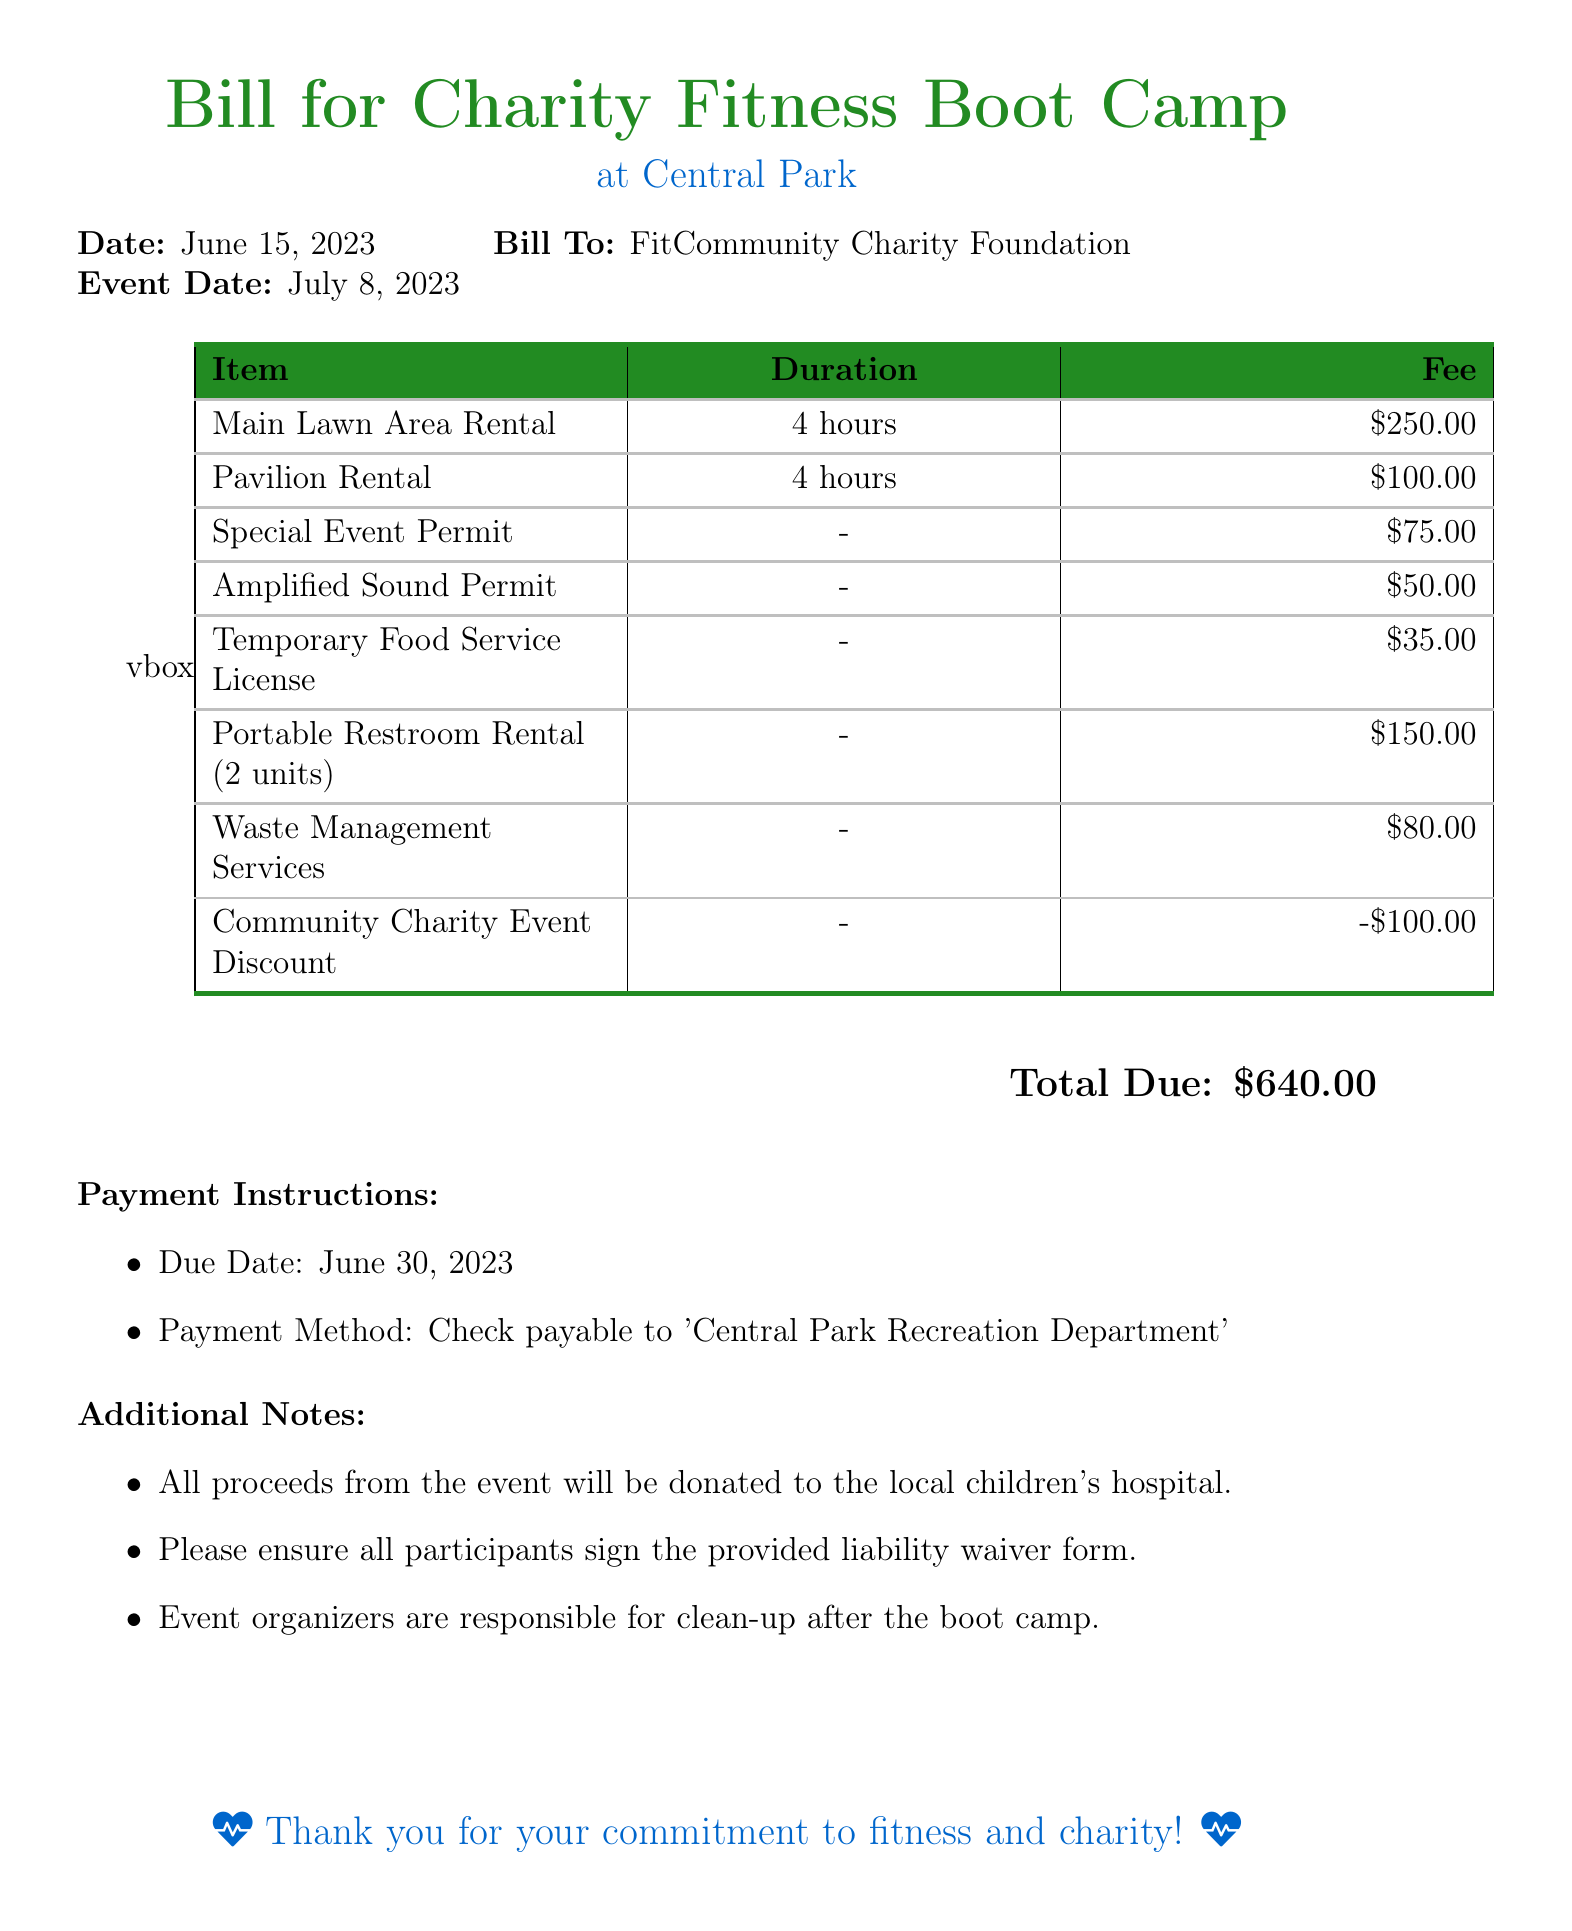What is the event date? The event date is specified in the document as July 8, 2023.
Answer: July 8, 2023 Who is the bill addressed to? The bill is addressed to the FitCommunity Charity Foundation.
Answer: FitCommunity Charity Foundation What is the fee for the Main Lawn Area Rental? The fee for the Main Lawn Area Rental is listed in the table as $250.00.
Answer: $250.00 What is the total due amount? The total due amount is calculated from the itemized fees, which is $640.00.
Answer: $640.00 What is the due date for payment? The due date for payment is June 30, 2023, as stated in the payment instructions.
Answer: June 30, 2023 Is there a discount applied? The document mentions a Community Charity Event Discount of $100.00.
Answer: $100.00 What services are included under Waste Management Services? The document indicates that Waste Management Services costs $80.00, but does not list specific services provided.
Answer: $80.00 What should participants sign? The document notes that all participants must sign a provided liability waiver form.
Answer: liability waiver form What will the proceeds from the event be donated to? The document states that all proceeds will be donated to the local children's hospital.
Answer: local children's hospital 